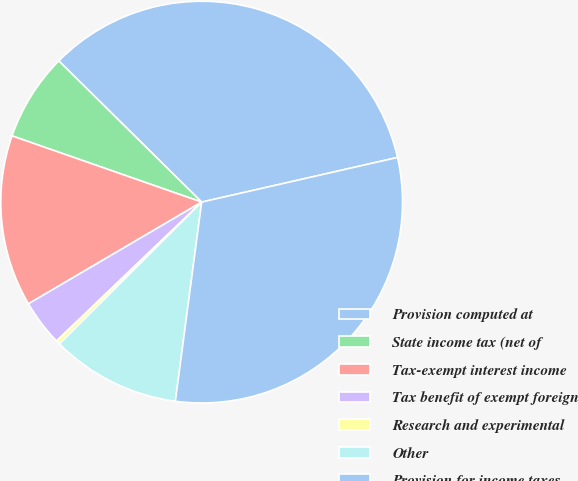Convert chart to OTSL. <chart><loc_0><loc_0><loc_500><loc_500><pie_chart><fcel>Provision computed at<fcel>State income tax (net of<fcel>Tax-exempt interest income<fcel>Tax benefit of exempt foreign<fcel>Research and experimental<fcel>Other<fcel>Provision for income taxes<nl><fcel>34.03%<fcel>7.06%<fcel>13.8%<fcel>3.7%<fcel>0.33%<fcel>10.43%<fcel>30.66%<nl></chart> 